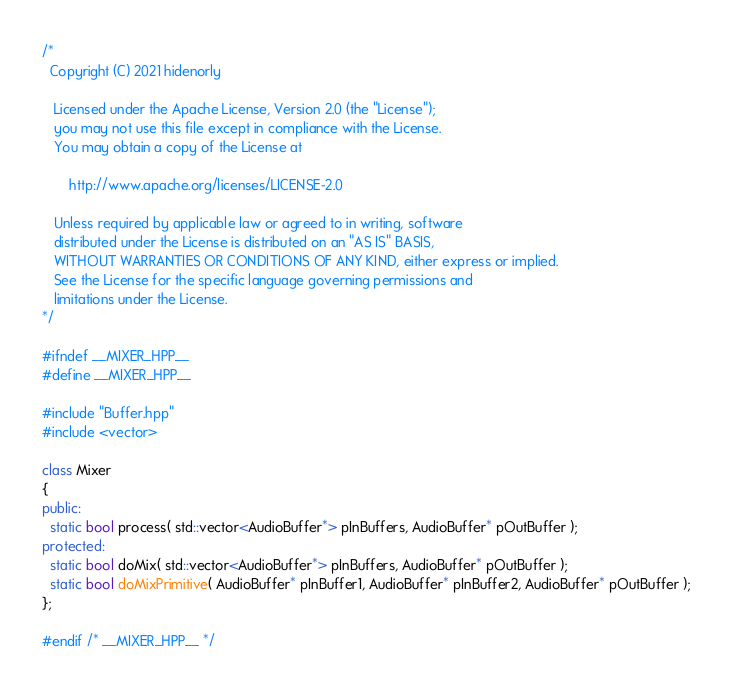<code> <loc_0><loc_0><loc_500><loc_500><_C++_>/* 
  Copyright (C) 2021 hidenorly

   Licensed under the Apache License, Version 2.0 (the "License");
   you may not use this file except in compliance with the License.
   You may obtain a copy of the License at

       http://www.apache.org/licenses/LICENSE-2.0

   Unless required by applicable law or agreed to in writing, software
   distributed under the License is distributed on an "AS IS" BASIS,
   WITHOUT WARRANTIES OR CONDITIONS OF ANY KIND, either express or implied.
   See the License for the specific language governing permissions and
   limitations under the License.
*/

#ifndef __MIXER_HPP__
#define __MIXER_HPP__

#include "Buffer.hpp"
#include <vector>

class Mixer
{
public:
  static bool process( std::vector<AudioBuffer*> pInBuffers, AudioBuffer* pOutBuffer );
protected:
  static bool doMix( std::vector<AudioBuffer*> pInBuffers, AudioBuffer* pOutBuffer );
  static bool doMixPrimitive( AudioBuffer* pInBuffer1, AudioBuffer* pInBuffer2, AudioBuffer* pOutBuffer );
};

#endif /* __MIXER_HPP__ */</code> 